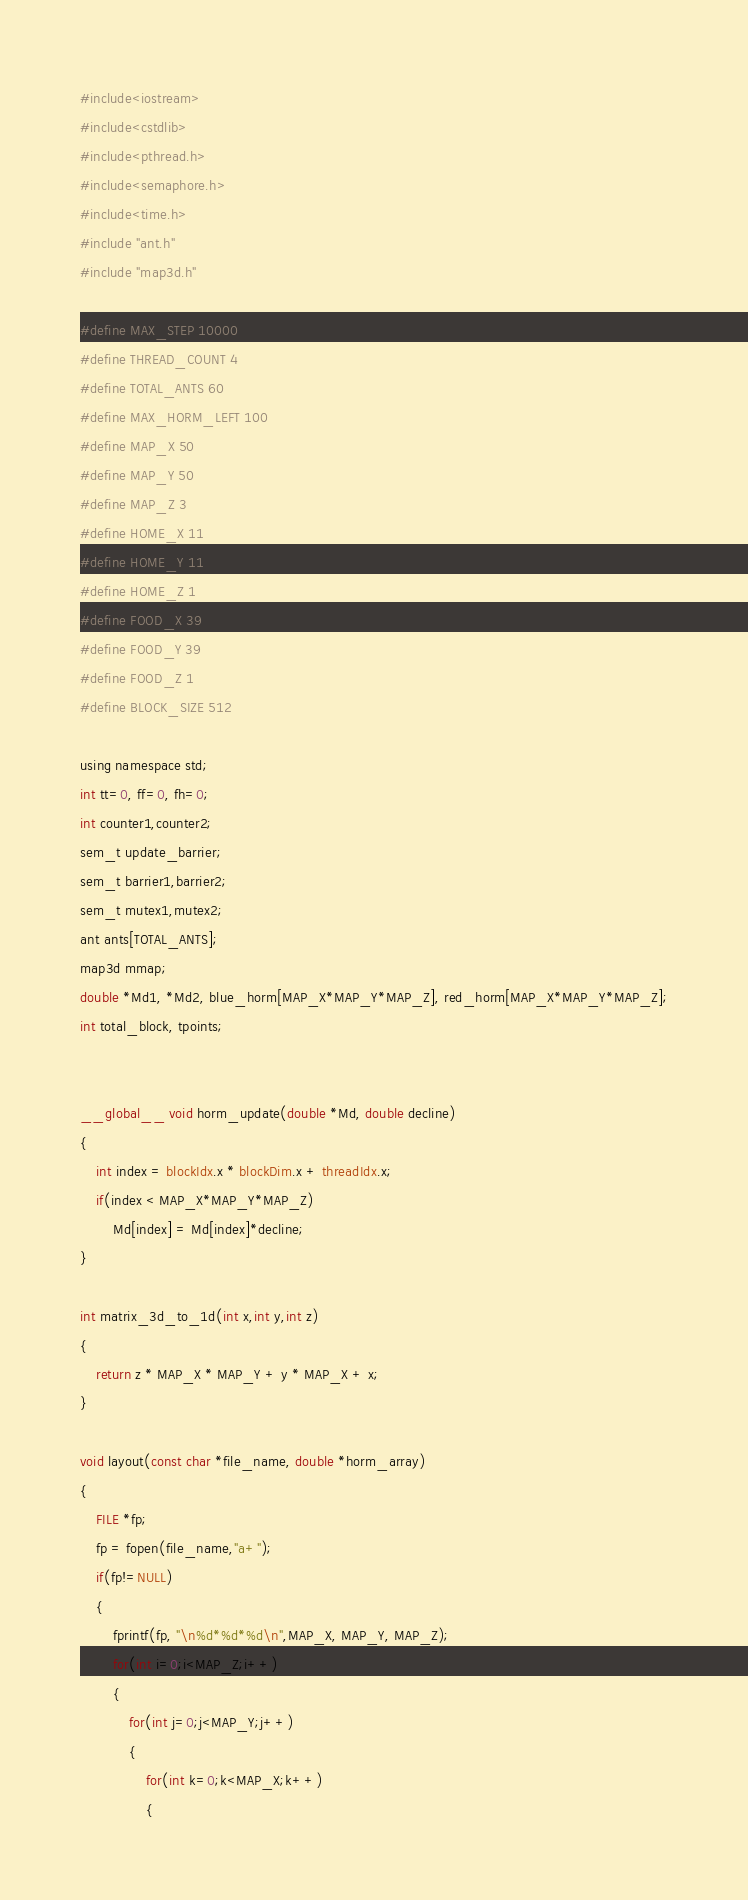Convert code to text. <code><loc_0><loc_0><loc_500><loc_500><_Cuda_>#include<iostream>
#include<cstdlib>
#include<pthread.h>
#include<semaphore.h>
#include<time.h>
#include "ant.h"
#include "map3d.h"

#define MAX_STEP 10000
#define THREAD_COUNT 4
#define TOTAL_ANTS 60
#define MAX_HORM_LEFT 100
#define MAP_X 50
#define MAP_Y 50
#define MAP_Z 3
#define HOME_X 11
#define HOME_Y 11
#define HOME_Z 1
#define FOOD_X 39
#define FOOD_Y 39
#define FOOD_Z 1
#define BLOCK_SIZE 512

using namespace std;
int tt=0, ff=0, fh=0;
int counter1,counter2;
sem_t update_barrier;
sem_t barrier1,barrier2;
sem_t mutex1,mutex2;
ant ants[TOTAL_ANTS];
map3d mmap;
double *Md1, *Md2, blue_horm[MAP_X*MAP_Y*MAP_Z], red_horm[MAP_X*MAP_Y*MAP_Z];
int total_block, tpoints;


__global__ void horm_update(double *Md, double decline)
{
	int index = blockIdx.x * blockDim.x + threadIdx.x;
	if(index < MAP_X*MAP_Y*MAP_Z)
        Md[index] = Md[index]*decline;
}

int matrix_3d_to_1d(int x,int y,int z)
{
    return z * MAP_X * MAP_Y + y * MAP_X + x;
}

void layout(const char *file_name, double *horm_array)
{
    FILE *fp;
    fp = fopen(file_name,"a+");
    if(fp!=NULL)
    {
        fprintf(fp, "\n%d*%d*%d\n",MAP_X, MAP_Y, MAP_Z);
        for(int i=0;i<MAP_Z;i++)
        {
            for(int j=0;j<MAP_Y;j++)
            {
                for(int k=0;k<MAP_X;k++)
                {</code> 